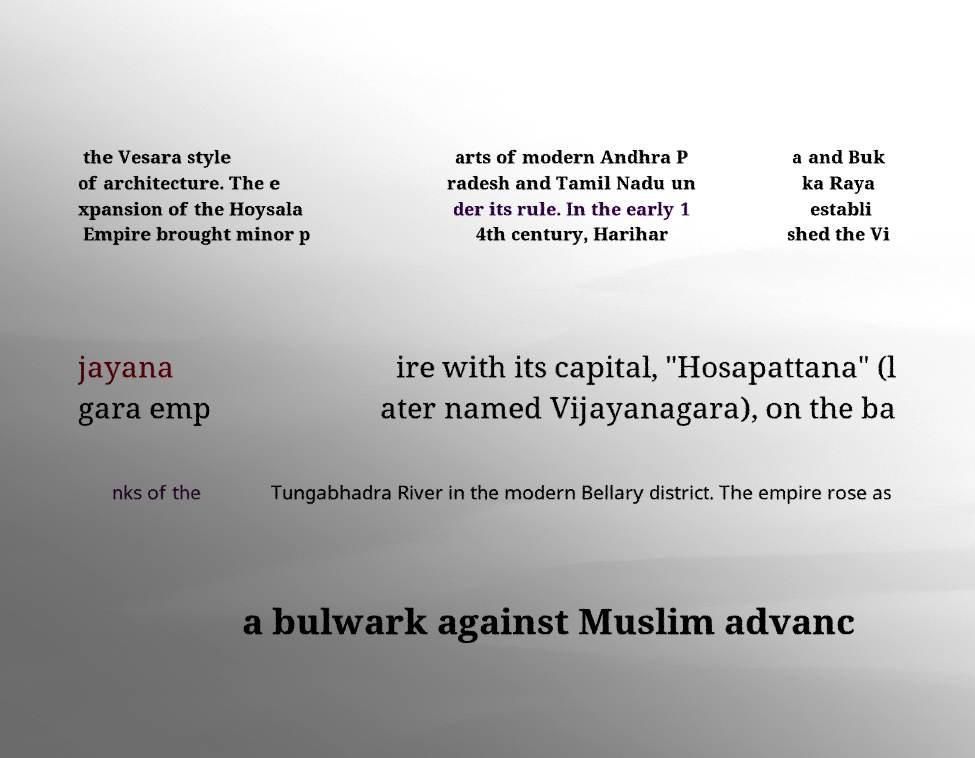Could you assist in decoding the text presented in this image and type it out clearly? the Vesara style of architecture. The e xpansion of the Hoysala Empire brought minor p arts of modern Andhra P radesh and Tamil Nadu un der its rule. In the early 1 4th century, Harihar a and Buk ka Raya establi shed the Vi jayana gara emp ire with its capital, "Hosapattana" (l ater named Vijayanagara), on the ba nks of the Tungabhadra River in the modern Bellary district. The empire rose as a bulwark against Muslim advanc 